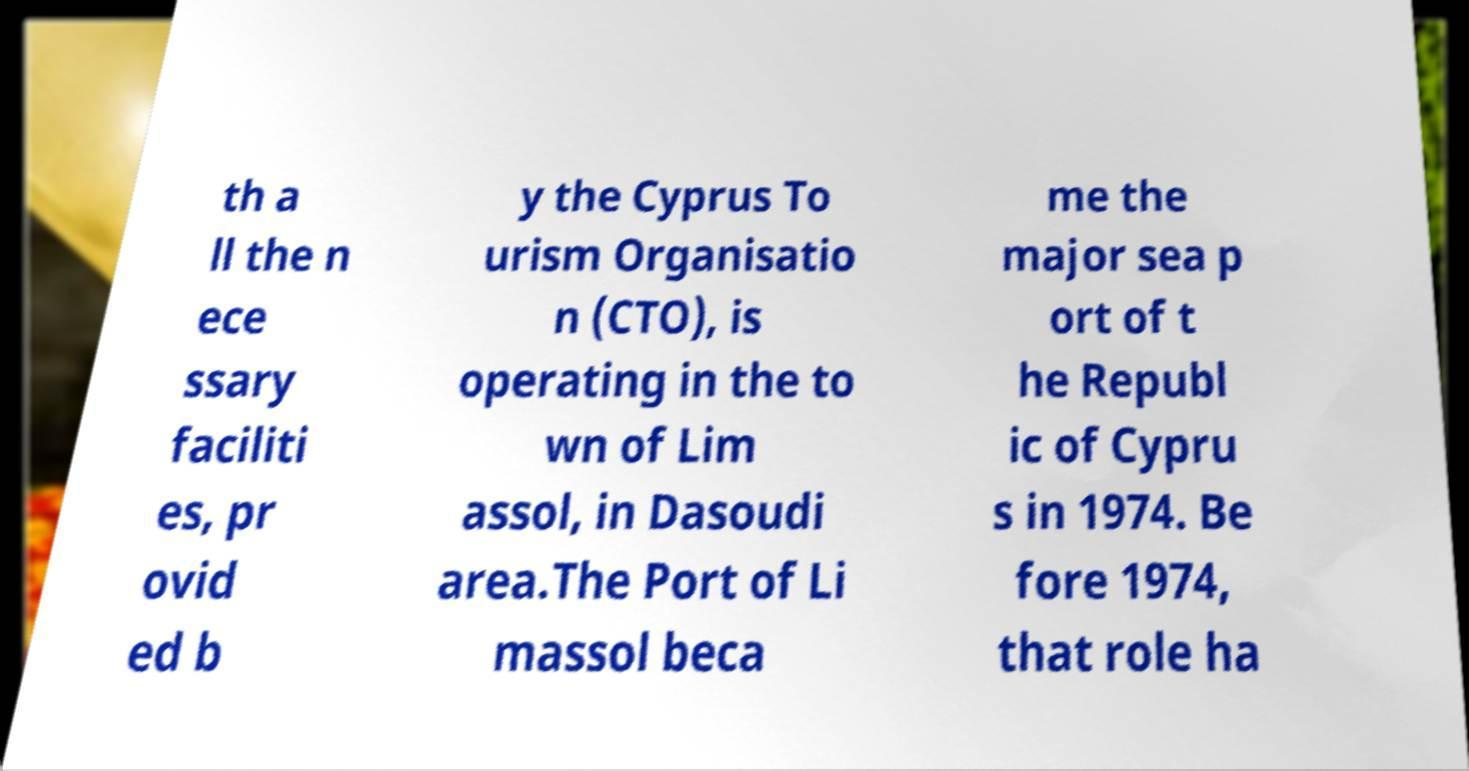Could you assist in decoding the text presented in this image and type it out clearly? th a ll the n ece ssary faciliti es, pr ovid ed b y the Cyprus To urism Organisatio n (CTO), is operating in the to wn of Lim assol, in Dasoudi area.The Port of Li massol beca me the major sea p ort of t he Republ ic of Cypru s in 1974. Be fore 1974, that role ha 